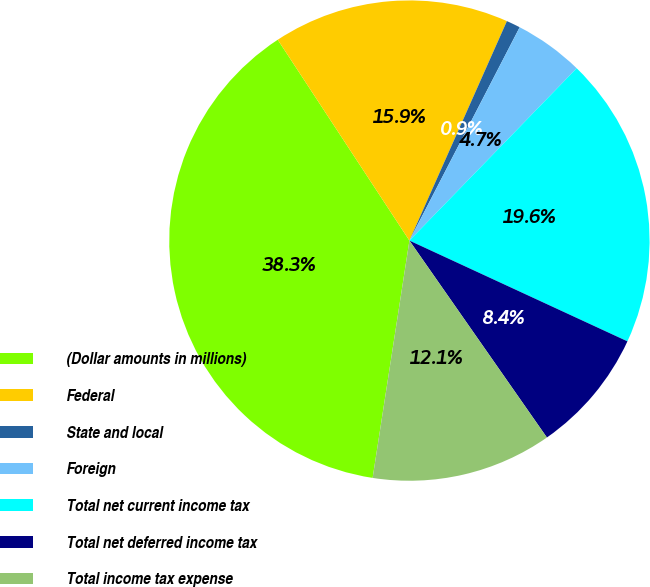<chart> <loc_0><loc_0><loc_500><loc_500><pie_chart><fcel>(Dollar amounts in millions)<fcel>Federal<fcel>State and local<fcel>Foreign<fcel>Total net current income tax<fcel>Total net deferred income tax<fcel>Total income tax expense<nl><fcel>38.32%<fcel>15.89%<fcel>0.94%<fcel>4.67%<fcel>19.63%<fcel>8.41%<fcel>12.15%<nl></chart> 